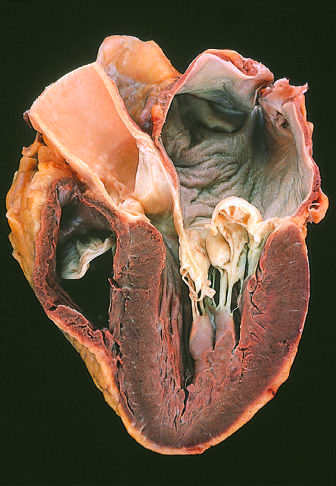s the left ventricle shown on the right in this four-chamber view?
Answer the question using a single word or phrase. Yes 